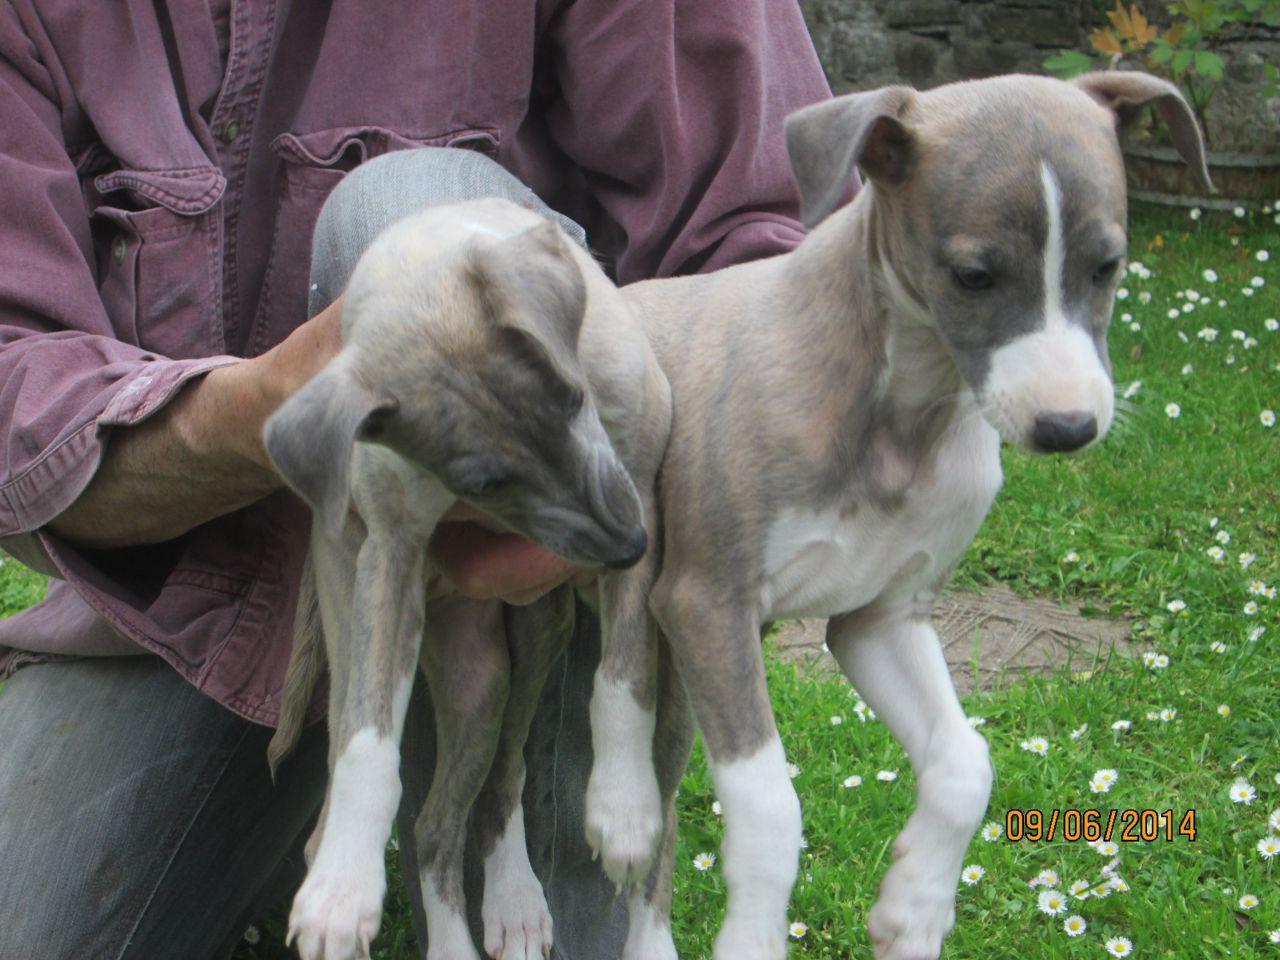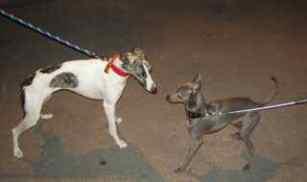The first image is the image on the left, the second image is the image on the right. Assess this claim about the two images: "There are 4 or more dogs, and at least two of them are touching.". Correct or not? Answer yes or no. Yes. The first image is the image on the left, the second image is the image on the right. Examine the images to the left and right. Is the description "An image shows two similarly colored, non-standing dogs side-by-side." accurate? Answer yes or no. Yes. 